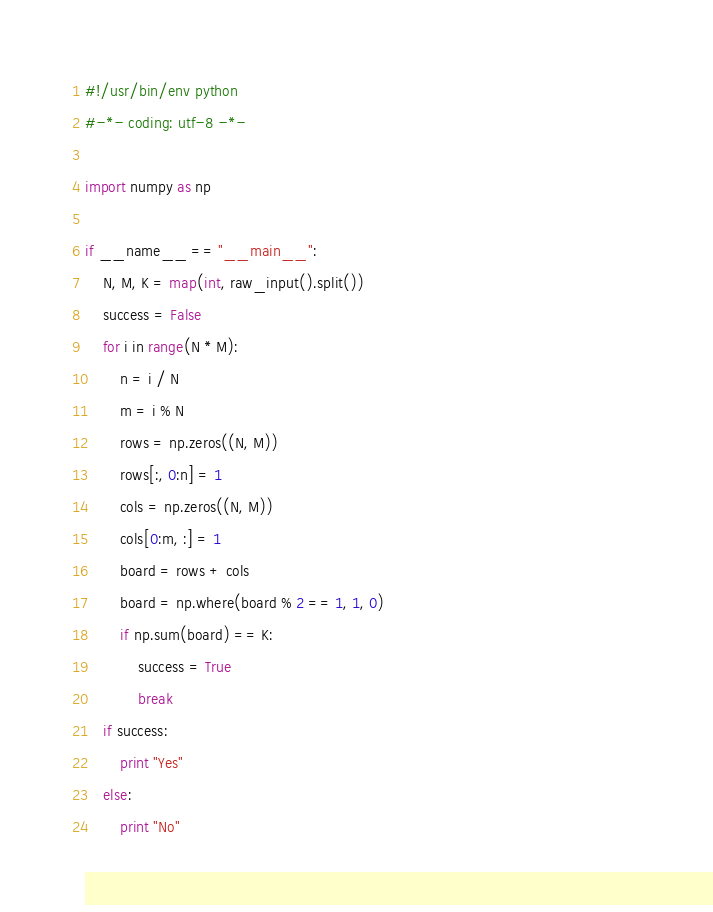Convert code to text. <code><loc_0><loc_0><loc_500><loc_500><_Python_>#!/usr/bin/env python                                                                                           
#-*- coding: utf-8 -*-                                                                                          

import numpy as np

if __name__ == "__main__":
    N, M, K = map(int, raw_input().split())
    success = False
    for i in range(N * M):
        n = i / N
        m = i % N
        rows = np.zeros((N, M))
        rows[:, 0:n] = 1
        cols = np.zeros((N, M))
        cols[0:m, :] = 1
        board = rows + cols
        board = np.where(board % 2 == 1, 1, 0)
        if np.sum(board) == K:
            success = True
            break
    if success:
        print "Yes"
    else:
        print "No"
</code> 